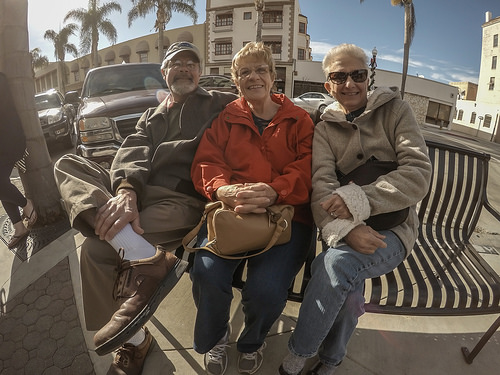<image>
Is the bag on the man? No. The bag is not positioned on the man. They may be near each other, but the bag is not supported by or resting on top of the man. Is there a man to the left of the woman? Yes. From this viewpoint, the man is positioned to the left side relative to the woman. 